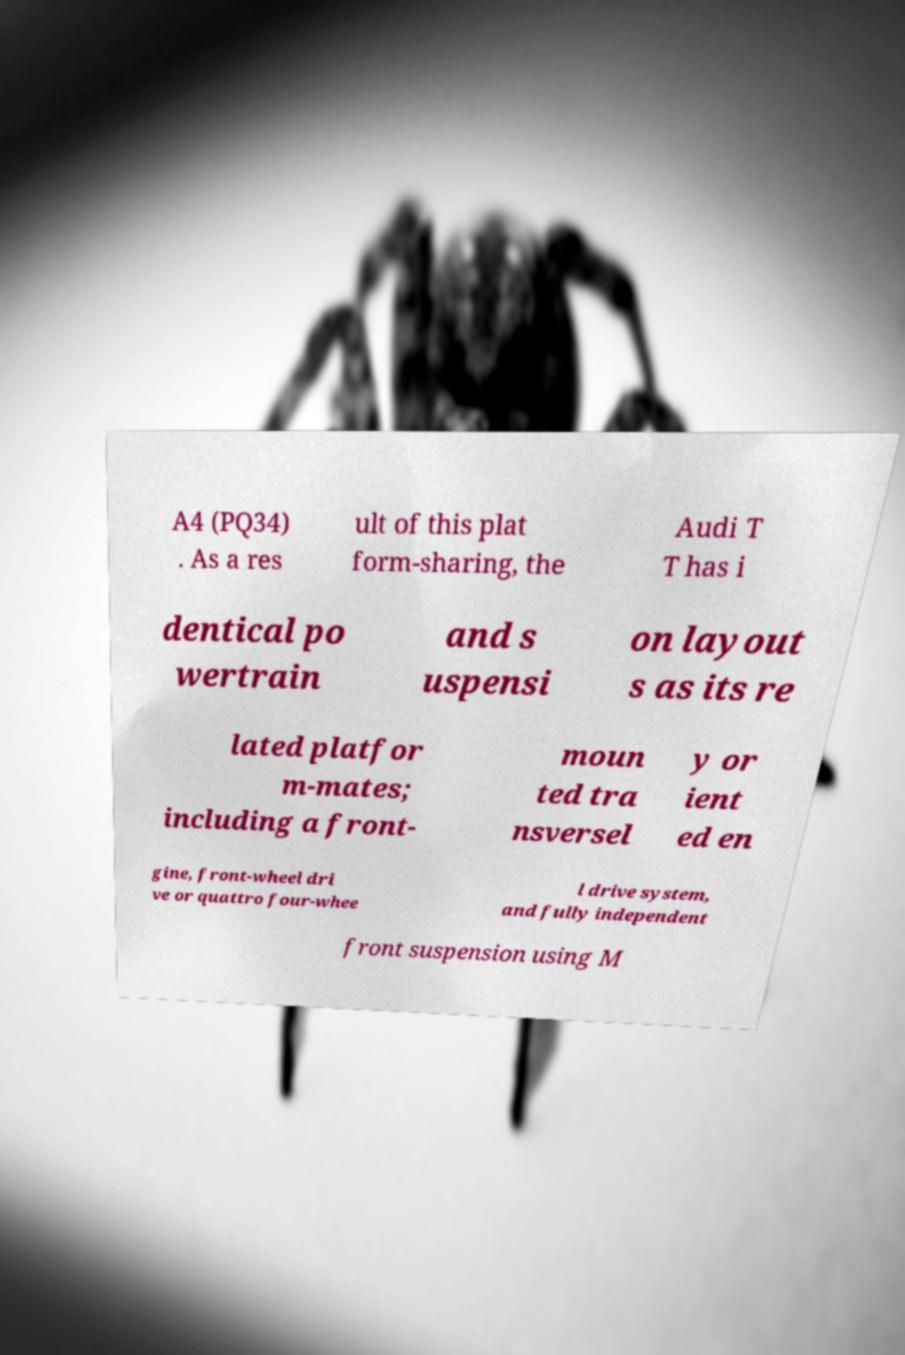Could you assist in decoding the text presented in this image and type it out clearly? A4 (PQ34) . As a res ult of this plat form-sharing, the Audi T T has i dentical po wertrain and s uspensi on layout s as its re lated platfor m-mates; including a front- moun ted tra nsversel y or ient ed en gine, front-wheel dri ve or quattro four-whee l drive system, and fully independent front suspension using M 